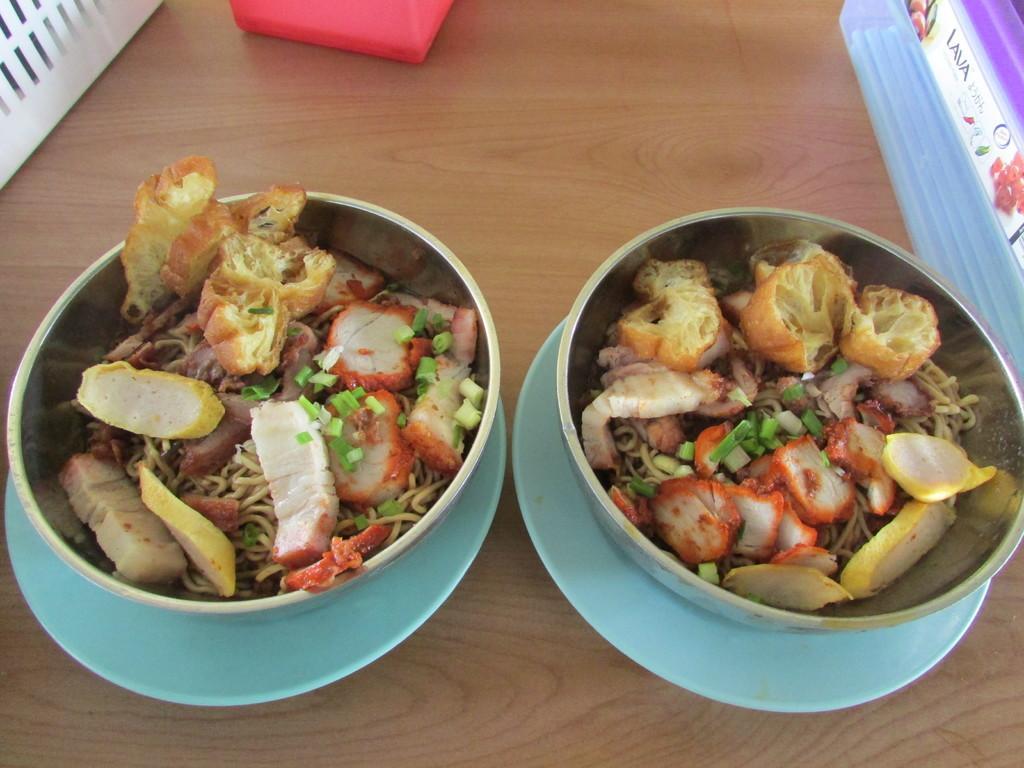Can you describe this image briefly? In this image we can see some food items are kept in the bowl which is placed on the plate and which are placed on the wooden surface. Here we can see a few more objects. 